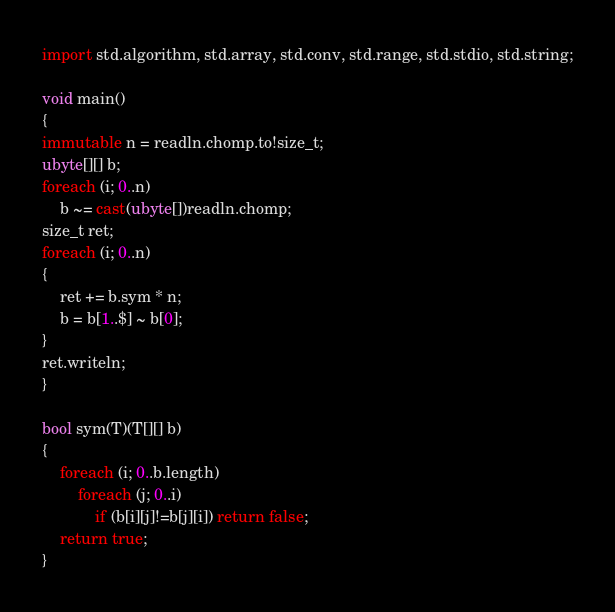Convert code to text. <code><loc_0><loc_0><loc_500><loc_500><_D_>import std.algorithm, std.array, std.conv, std.range, std.stdio, std.string;

void main()
{
immutable n = readln.chomp.to!size_t;
ubyte[][] b;
foreach (i; 0..n)
    b ~= cast(ubyte[])readln.chomp;
size_t ret;
foreach (i; 0..n)
{
    ret += b.sym * n;
    b = b[1..$] ~ b[0];
}
ret.writeln;
}

bool sym(T)(T[][] b)
{
    foreach (i; 0..b.length)
        foreach (j; 0..i)
            if (b[i][j]!=b[j][i]) return false;
    return true;
}</code> 